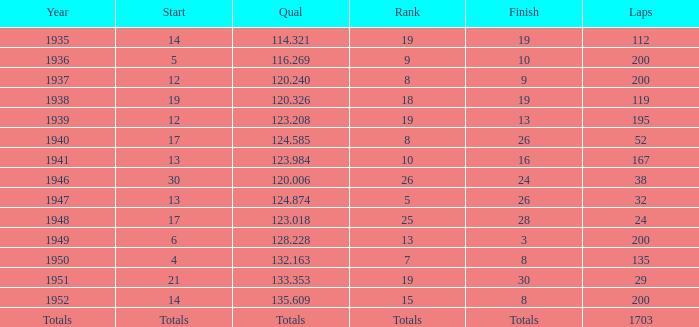With a Rank of 19, and a Start of 14, what was the finish? 19.0. 